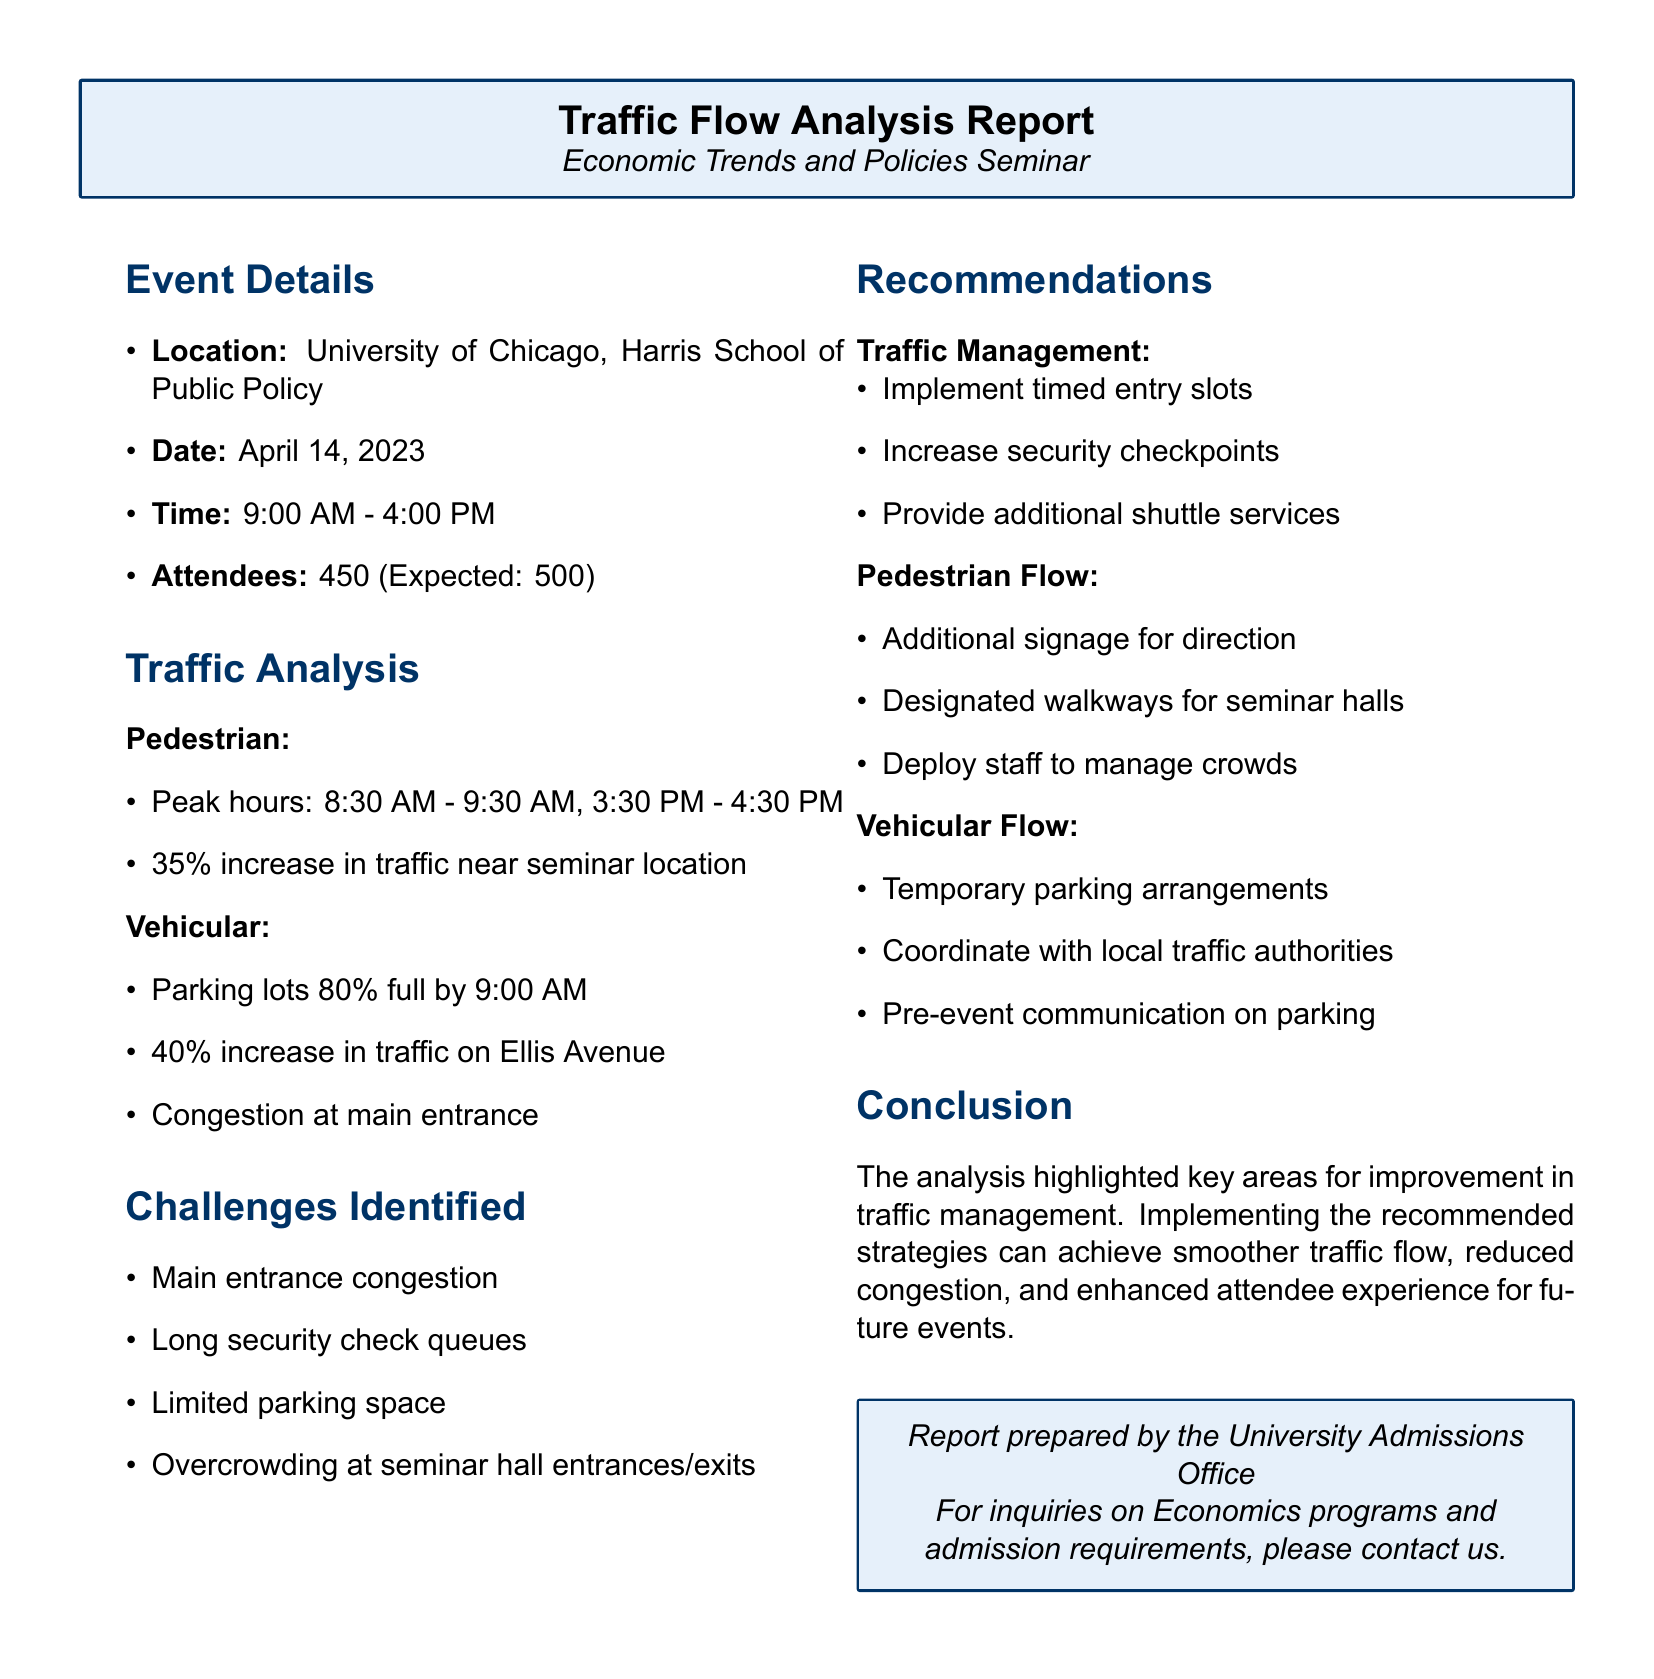What is the date of the event? The date of the event is clearly stated in the document as April 14, 2023.
Answer: April 14, 2023 How many attendees were expected? The document mentions that the expected number of attendees was 500.
Answer: 500 What was the peak hour for pedestrian traffic? The document specifies the peak hours for pedestrian traffic as 8:30 AM - 9:30 AM.
Answer: 8:30 AM - 9:30 AM What percentage increase in traffic was observed near the seminar location? The document indicates a 35% increase in traffic near the seminar location.
Answer: 35% What challenges were identified in the report? The report outlines several challenges, including congestion at the main entrance and long security check queues.
Answer: Congestion at main entrance What recommendations were made for improving pedestrian flow? The recommendations for improving pedestrian flow included additional signage for direction and designated walkways.
Answer: Additional signage for direction How full were the parking lots by 9:00 AM? According to the document, the parking lots were 80% full by 9:00 AM.
Answer: 80% full What is one recommended strategy for traffic management? The document suggests implementing timed entry slots as a strategy for traffic management.
Answer: Timed entry slots What is the purpose of this report? The report is prepared by the University Admissions Office for inquiries related to Economics programs and admission requirements.
Answer: Inquiries on Economics programs 